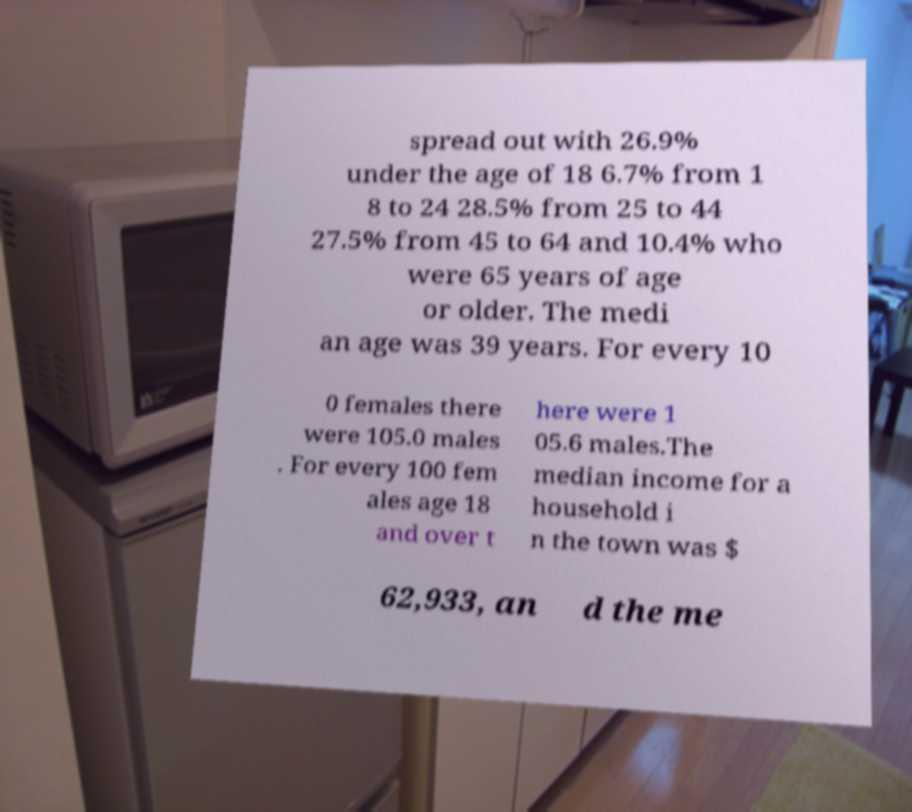There's text embedded in this image that I need extracted. Can you transcribe it verbatim? spread out with 26.9% under the age of 18 6.7% from 1 8 to 24 28.5% from 25 to 44 27.5% from 45 to 64 and 10.4% who were 65 years of age or older. The medi an age was 39 years. For every 10 0 females there were 105.0 males . For every 100 fem ales age 18 and over t here were 1 05.6 males.The median income for a household i n the town was $ 62,933, an d the me 